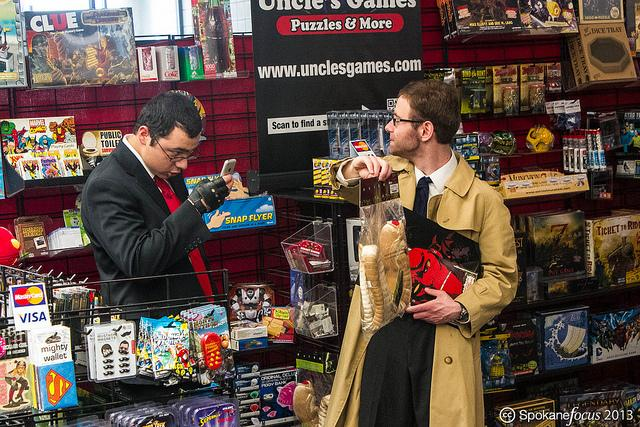What superhero's logo is printed on a wallet in front of the Visa sign? Please explain your reasoning. superman. The blue, red, and white s is well known to be the symbol for superman, as that appears on his cape. 